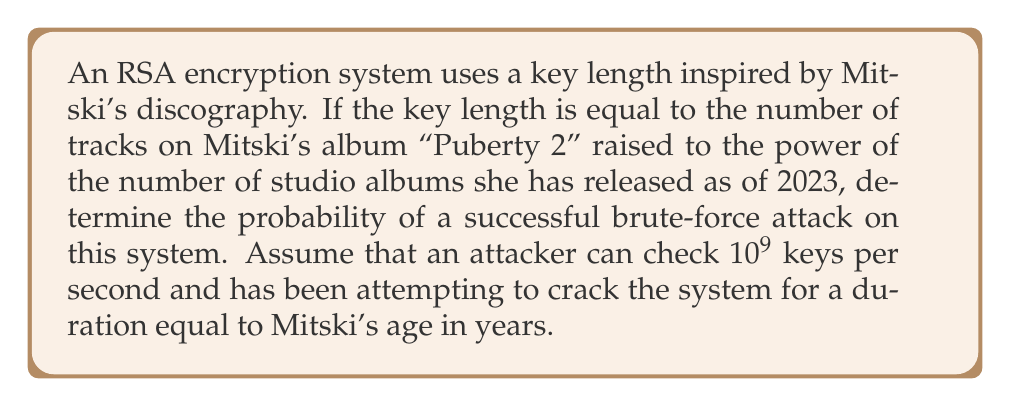Can you answer this question? Let's approach this step-by-step:

1. Determine the key length:
   - Mitski's album "Puberty 2" has 11 tracks
   - As of 2023, Mitski has released 6 studio albums
   - Key length = $11^6 = 1,771,561$ bits

2. Calculate the total number of possible keys:
   $N = 2^{1,771,561}$

3. Calculate the number of keys the attacker has checked:
   - Mitski was born in 1990, so in 2023 she is 33 years old
   - Time in seconds: $33 \times 365 \times 24 \times 60 \times 60 = 1,040,688,000$ seconds
   - Keys checked: $1,040,688,000 \times 10^9 = 1.040688 \times 10^{18}$

4. Calculate the probability of success:
   $$P(\text{success}) = \frac{\text{Keys checked}}{\text{Total possible keys}} = \frac{1.040688 \times 10^{18}}{2^{1,771,561}}$$

5. Simplify:
   $$P(\text{success}) = \frac{1.040688 \times 10^{18}}{2^{1,771,561}} \approx 2.718 \times 10^{-533,452}$$

This probability is extremely small, effectively zero, indicating that a brute-force attack on this RSA system is practically impossible.
Answer: $2.718 \times 10^{-533,452}$ 